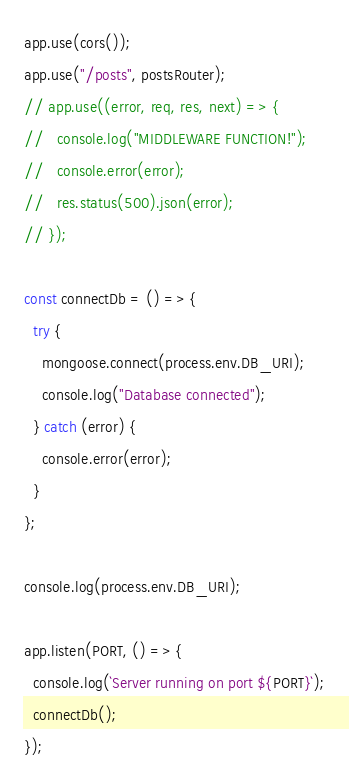Convert code to text. <code><loc_0><loc_0><loc_500><loc_500><_JavaScript_>app.use(cors());
app.use("/posts", postsRouter);
// app.use((error, req, res, next) => {
//   console.log("MIDDLEWARE FUNCTION!");
//   console.error(error);
//   res.status(500).json(error);
// });

const connectDb = () => {
  try {
    mongoose.connect(process.env.DB_URI);
    console.log("Database connected");
  } catch (error) {
    console.error(error);
  }
};

console.log(process.env.DB_URI);

app.listen(PORT, () => {
  console.log(`Server running on port ${PORT}`);
  connectDb();
});
</code> 